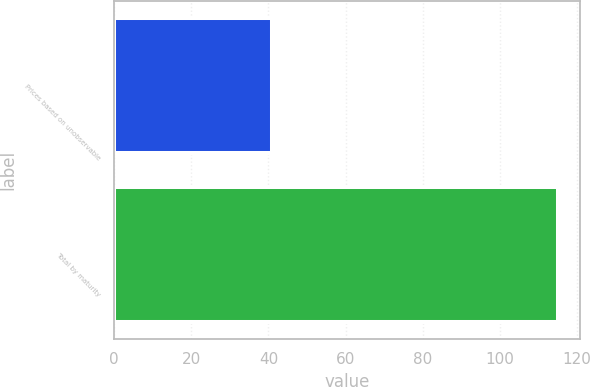Convert chart. <chart><loc_0><loc_0><loc_500><loc_500><bar_chart><fcel>Prices based on unobservable<fcel>Total by maturity<nl><fcel>41<fcel>115<nl></chart> 